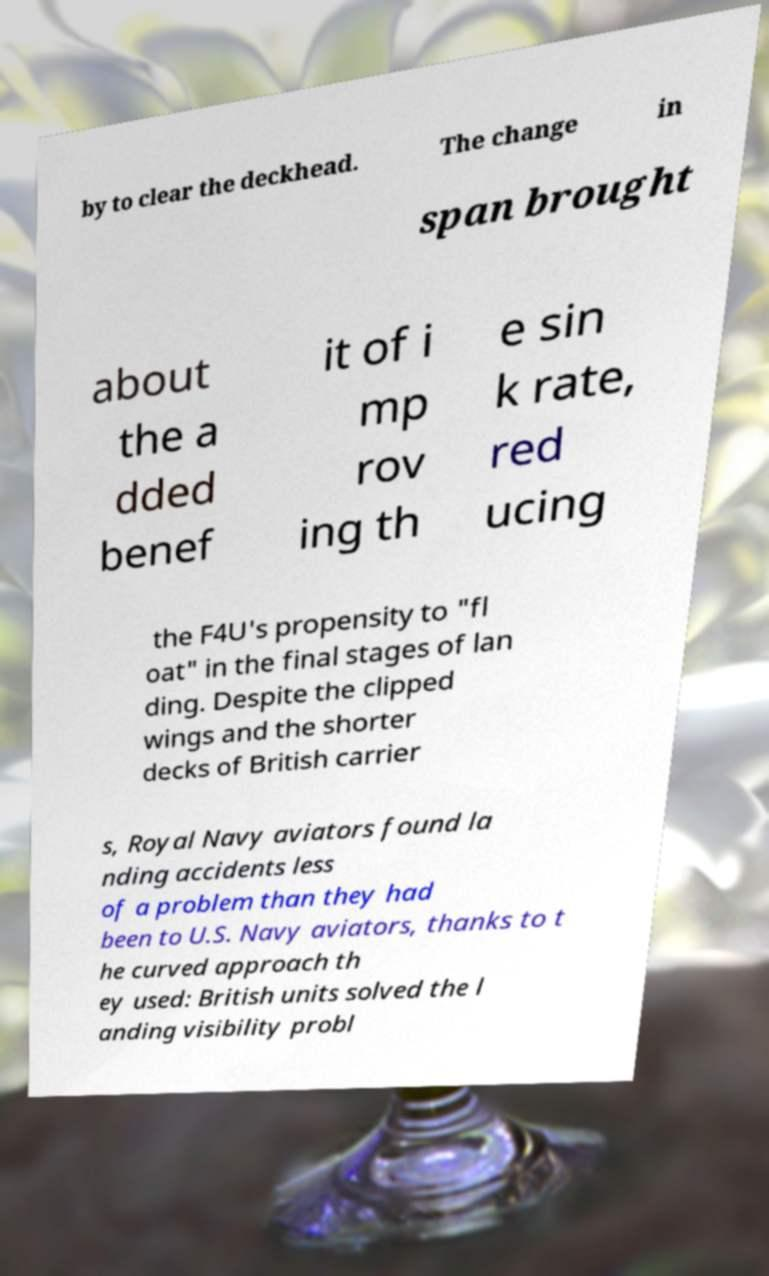Could you assist in decoding the text presented in this image and type it out clearly? by to clear the deckhead. The change in span brought about the a dded benef it of i mp rov ing th e sin k rate, red ucing the F4U's propensity to "fl oat" in the final stages of lan ding. Despite the clipped wings and the shorter decks of British carrier s, Royal Navy aviators found la nding accidents less of a problem than they had been to U.S. Navy aviators, thanks to t he curved approach th ey used: British units solved the l anding visibility probl 